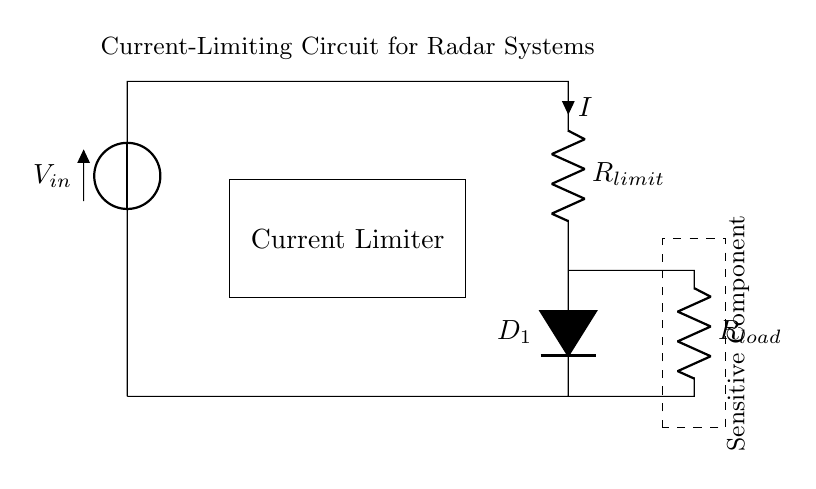What is the input voltage of the circuit? The input voltage is labeled as V in the circuit diagram, suggesting it is the source voltage feeding the circuit. Although the exact value isn't specified in the diagram, it represents the total voltage supplied to the circuit.
Answer: V What components limit the current in the circuit? The current limiting is primarily done by the resistor labeled R limit. This resistor will reduce the current flowing to the load and protect sensitive components from overcurrent.
Answer: R limit What type of diode is used in the circuit? The diode in the circuit is labeled as D one, which indicates it is a light-emitting diode (LED). In this context, it serves both as a current limiter and an indicator of current flow.
Answer: LED What might happen if the current exceeds the limit? If the current exceeds the limit set by R limit, it could potentially damage the sensitive component shown in the rectangle labeled "Sensitive Component". This is why a current-limiting circuit is essential.
Answer: Damage What is the purpose of R load in this circuit? R load serves as the load resistor that the sensitive components will connect to. It helps determine the overall current flow and can influence the voltage drop across R limit and the diode.
Answer: Load resistor Why is a dashed rectangle used in this diagram? The dashed rectangle indicates the area containing the sensitive component, delineating its boundaries and emphasizing the importance of current protection around it.
Answer: Protection area What does the label 'Current Limiter' refer to in this circuit? The label 'Current Limiter' identifies the portion of the circuit that is dedicated to restricting the current to prevent excessive flow which could cause damage to sensitive components in radar systems.
Answer: Current limiting mechanism 